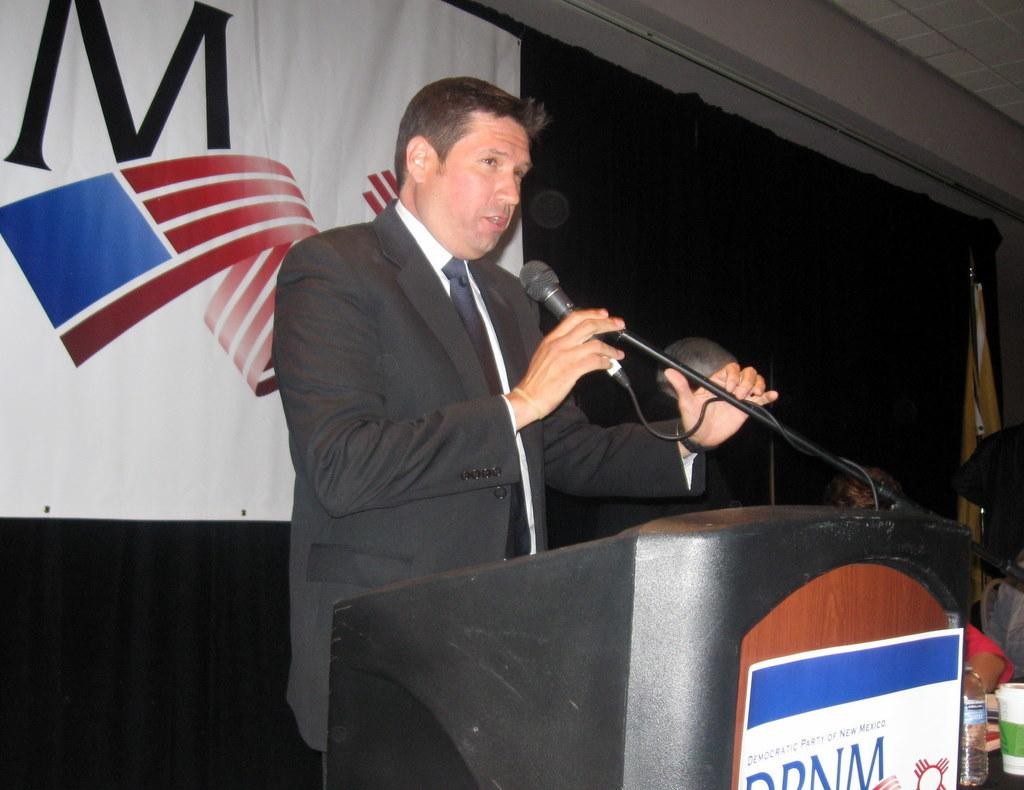Who is the main subject in the image? There is a man in the image. What is the man doing in the image? The man is speaking in the image. What object is the man holding in his right hand? The man is holding a microphone in his right hand. Can you describe the person sitting beside the man? There is another person sitting beside the man, but their specific actions or characteristics are not mentioned in the provided facts. How does the man's digestion process affect his speech in the image? There is no information about the man's digestion process in the image, so it cannot be determined how it might affect his speech. 